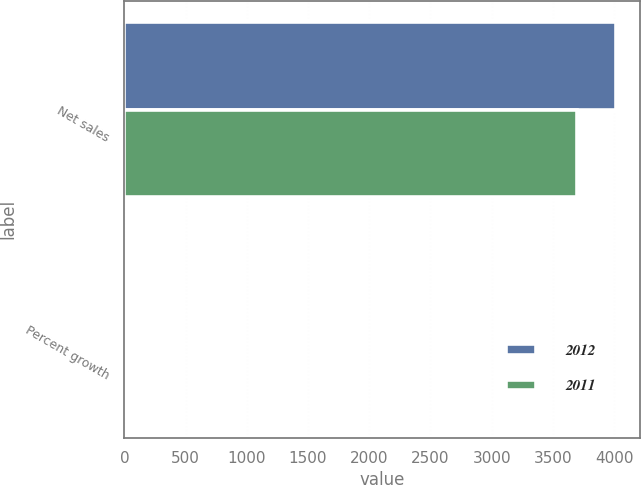<chart> <loc_0><loc_0><loc_500><loc_500><stacked_bar_chart><ecel><fcel>Net sales<fcel>Percent growth<nl><fcel>2012<fcel>4014.2<fcel>8.6<nl><fcel>2011<fcel>3697.6<fcel>10.8<nl></chart> 